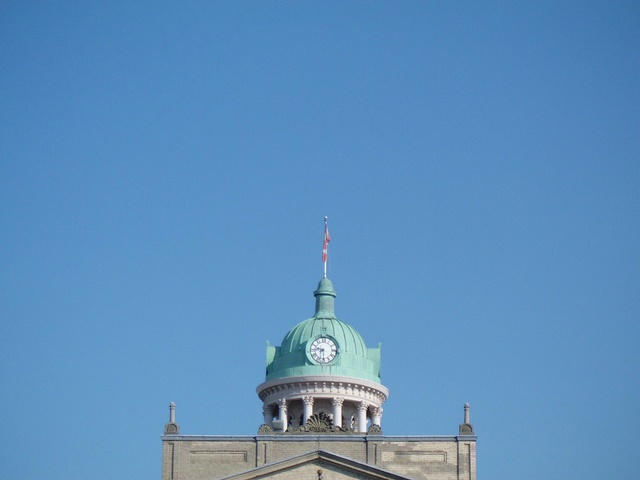Describe the objects in this image and their specific colors. I can see a clock in gray, lightgray, and darkgray tones in this image. 